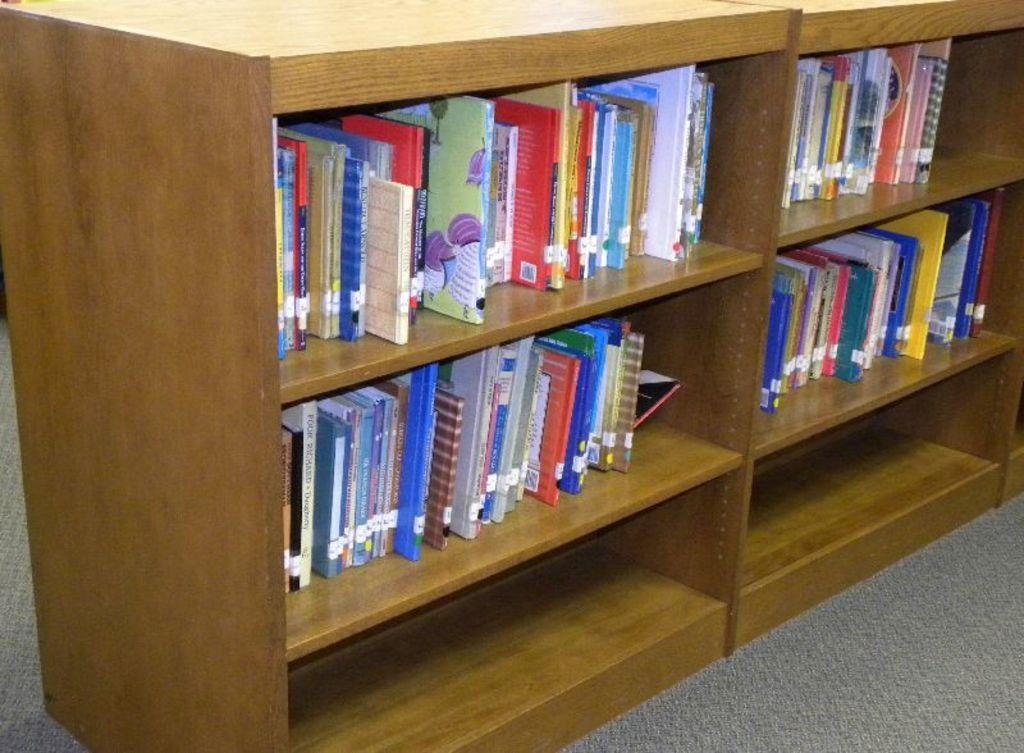What can be found inside the cupboards in the image? There are books in the cupboards. What is located at the bottom of the image? There is a mat at the bottom of the image. Can you describe the books in the cupboards? The books have text on them. Where is the bat resting in the image? There is no bat present in the image. What type of cushion is placed on the mat in the image? There is no cushion present in the image. 